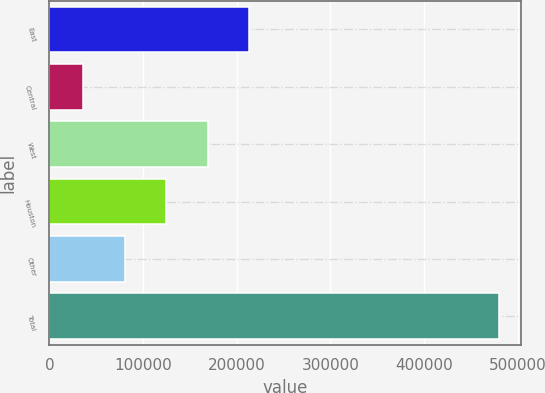Convert chart. <chart><loc_0><loc_0><loc_500><loc_500><bar_chart><fcel>East<fcel>Central<fcel>West<fcel>Houston<fcel>Other<fcel>Total<nl><fcel>213523<fcel>36158<fcel>169182<fcel>124841<fcel>80499.3<fcel>479571<nl></chart> 